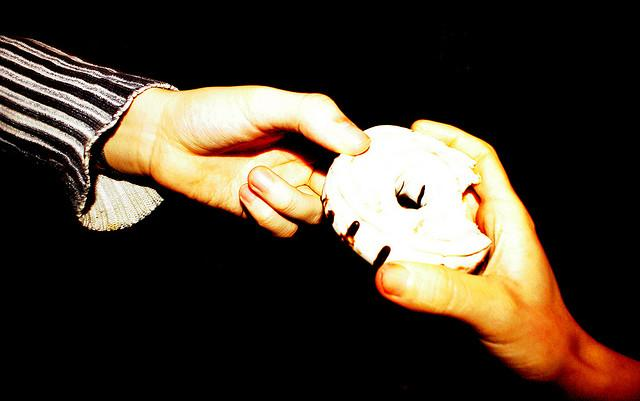Which person bit the donut?

Choices:
A) leftmost
B) baker
C) none
D) rightmost rightmost 